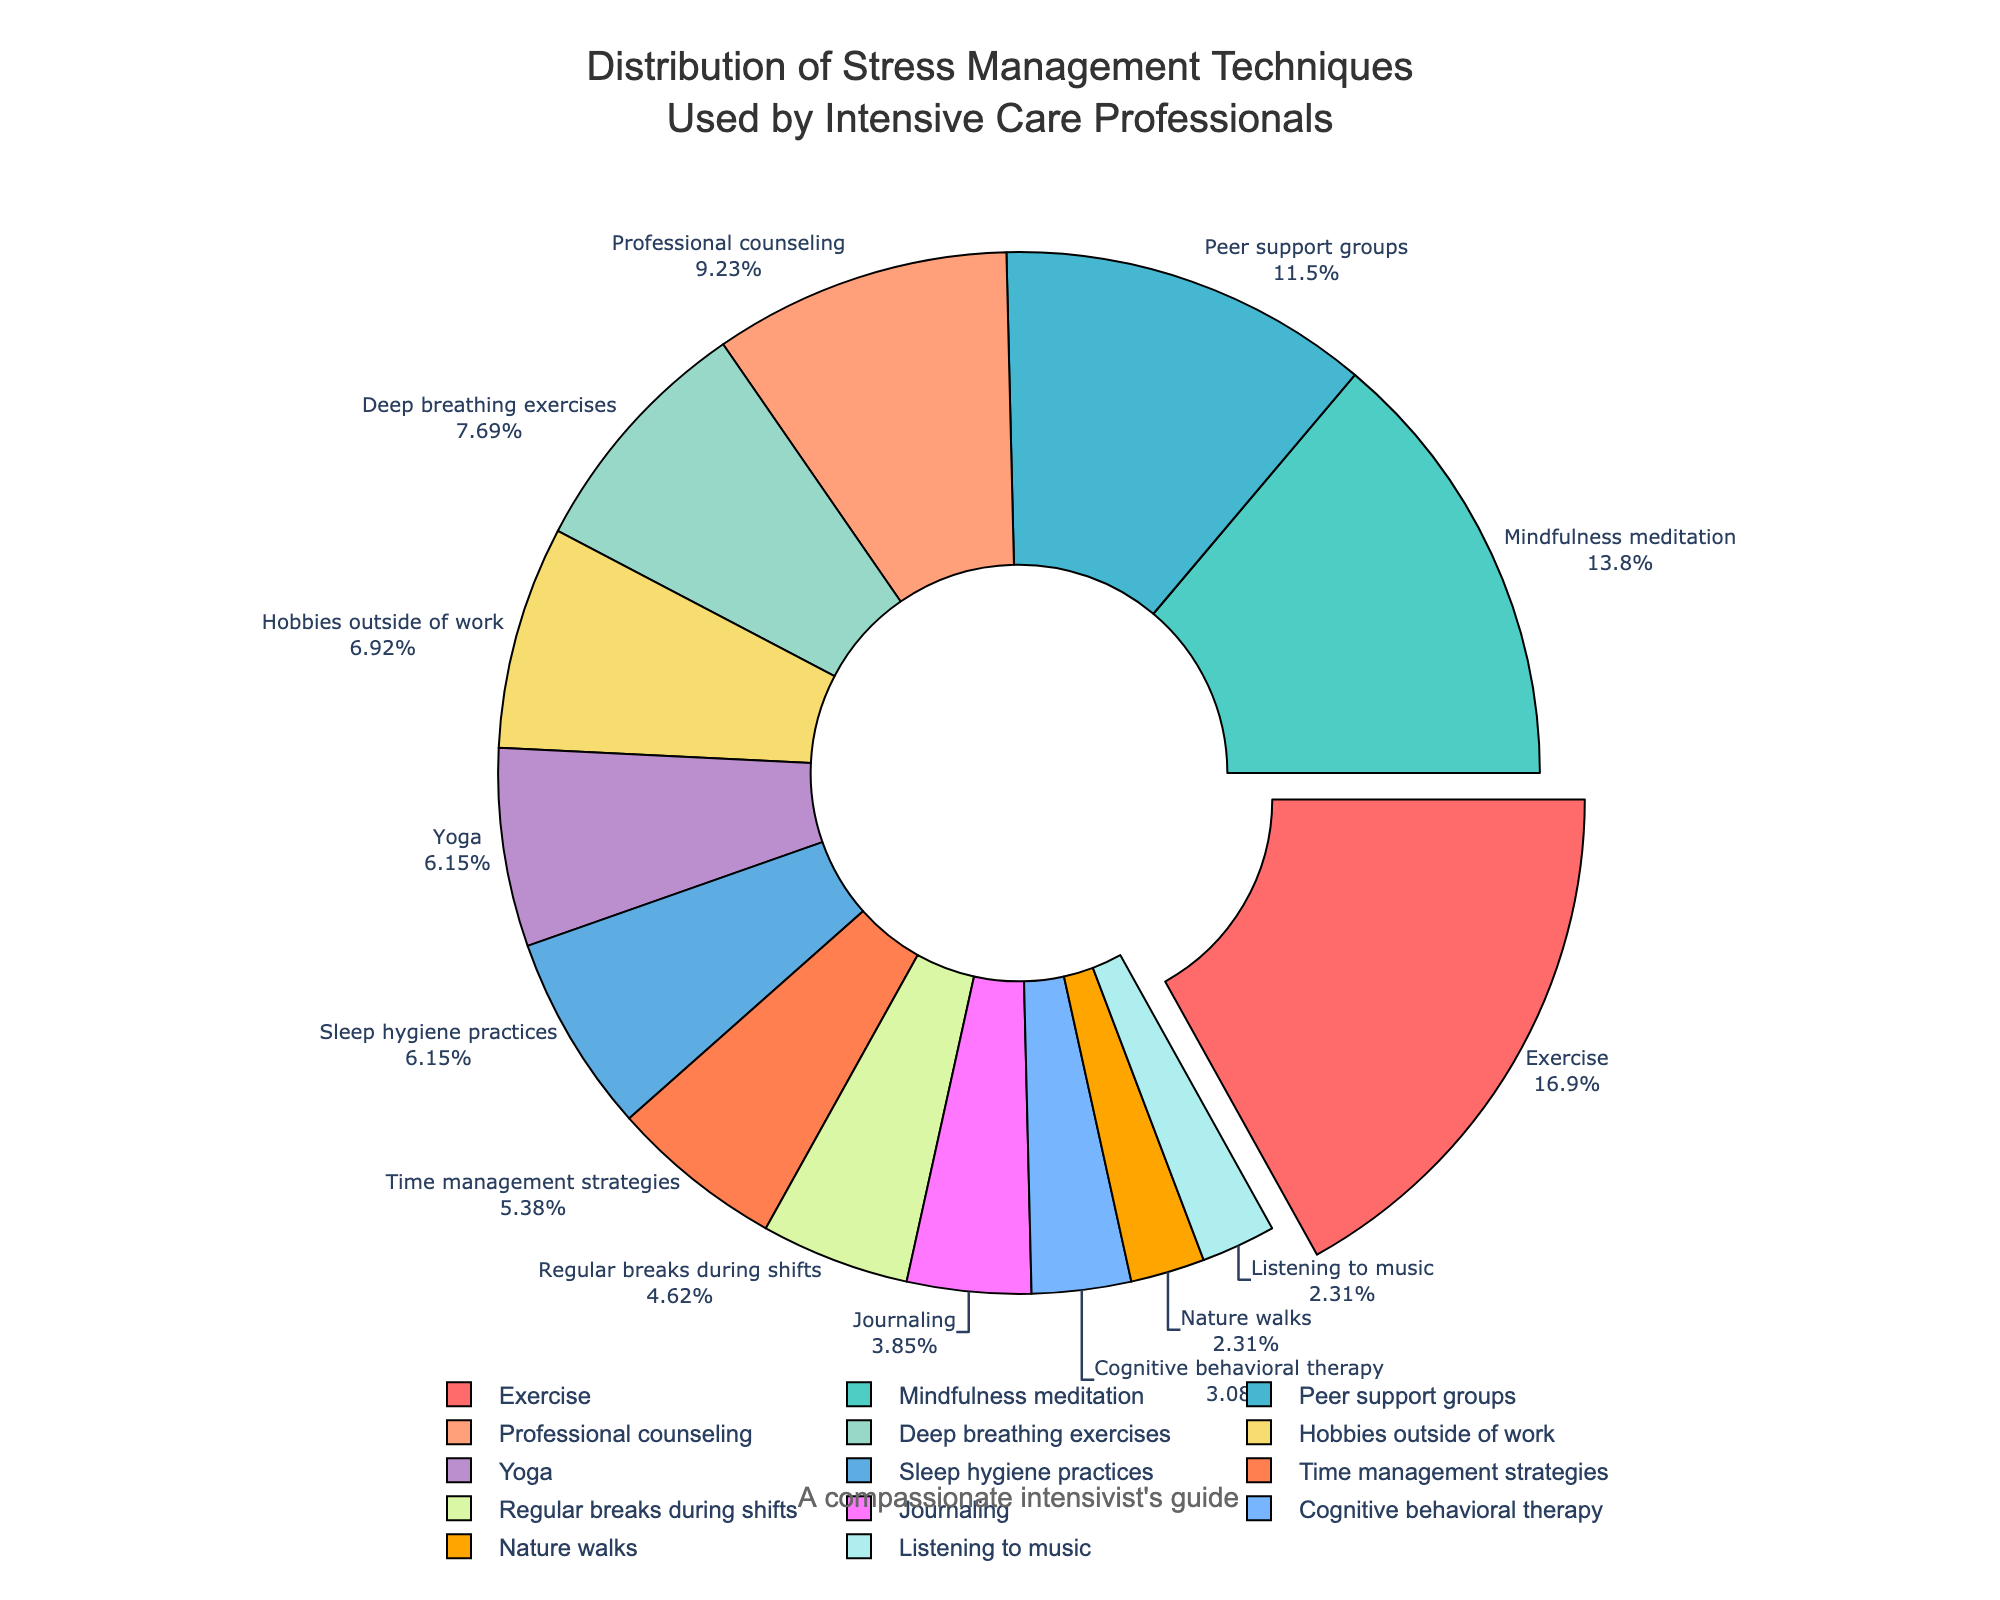How many techniques are used by at least 10% of participants? First, identify the techniques with percentages of 10 or more: Mindfulness meditation (18%), Exercise (22%), Peer support groups (15%), Professional counseling (12%), and Deep breathing exercises (10%). Count these identified techniques.
Answer: 5 Which technique is used most frequently by intensive care professionals? Locate the technique with the highest percentage. Exercise has the largest portion with 22%.
Answer: Exercise Compare the usage of mindfulness meditation and yoga. Which one is more popular and by what percentage difference? Identify the percentage for mindfulness meditation (18%) and yoga (8%). Subtract the latter from the former: 18% - 8%.
Answer: Mindfulness meditation by 10% What is the cumulative percentage of techniques related to physical activities (Exercise, Yoga, Nature walks)? Sum the percentages of Exercise (22%), Yoga (8%), and Nature walks (3%): 22% + 8% + 3%.
Answer: 33% Which technique related to mental health (mindfulness meditation, professional counseling, cognitive behavioral therapy) has the lowest adoption rate, and what is its percentage? Identify percentages for mindfulness meditation (18%), professional counseling (12%), and cognitive behavioral therapy (4%). The lowest is cognitive behavioral therapy.
Answer: 4% What is the total percentage of non-physical and non-mental health-related techniques? Sum the percentages for Time management strategies (7%), Hobbies outside of work (9%), Regular breaks during shifts (6%), and Listening to music (3%): 7% + 9% + 6% + 3%.
Answer: 25% By how much do professional counseling and peer support groups combined exceed the usage of journaling? Professional counseling (12%) and peer support groups (15%) sum to 27%. Subtract journaling’s percentage (5%) from 27%: 27% - 5%.
Answer: 22% What are the techniques used by less than 5% of participants, and what is the total percentage for these techniques? Identify the percentages for each technique: Journaling (5%), Cognitive behavioral therapy (4%), Nature walks (3%), Listening to music (3%). Sum those under 5%, excluding journaling: Cognitive behavioral therapy (4%) + Nature walks (3%) + Listening to music (3%): 4% + 3% + 3%.
Answer: 10% 